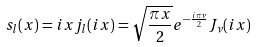<formula> <loc_0><loc_0><loc_500><loc_500>s _ { l } ( x ) = i x j _ { l } ( i x ) = \sqrt { \frac { \pi x } { 2 } } e ^ { - \frac { i \pi \nu } { 2 } } J _ { \nu } ( i x )</formula> 